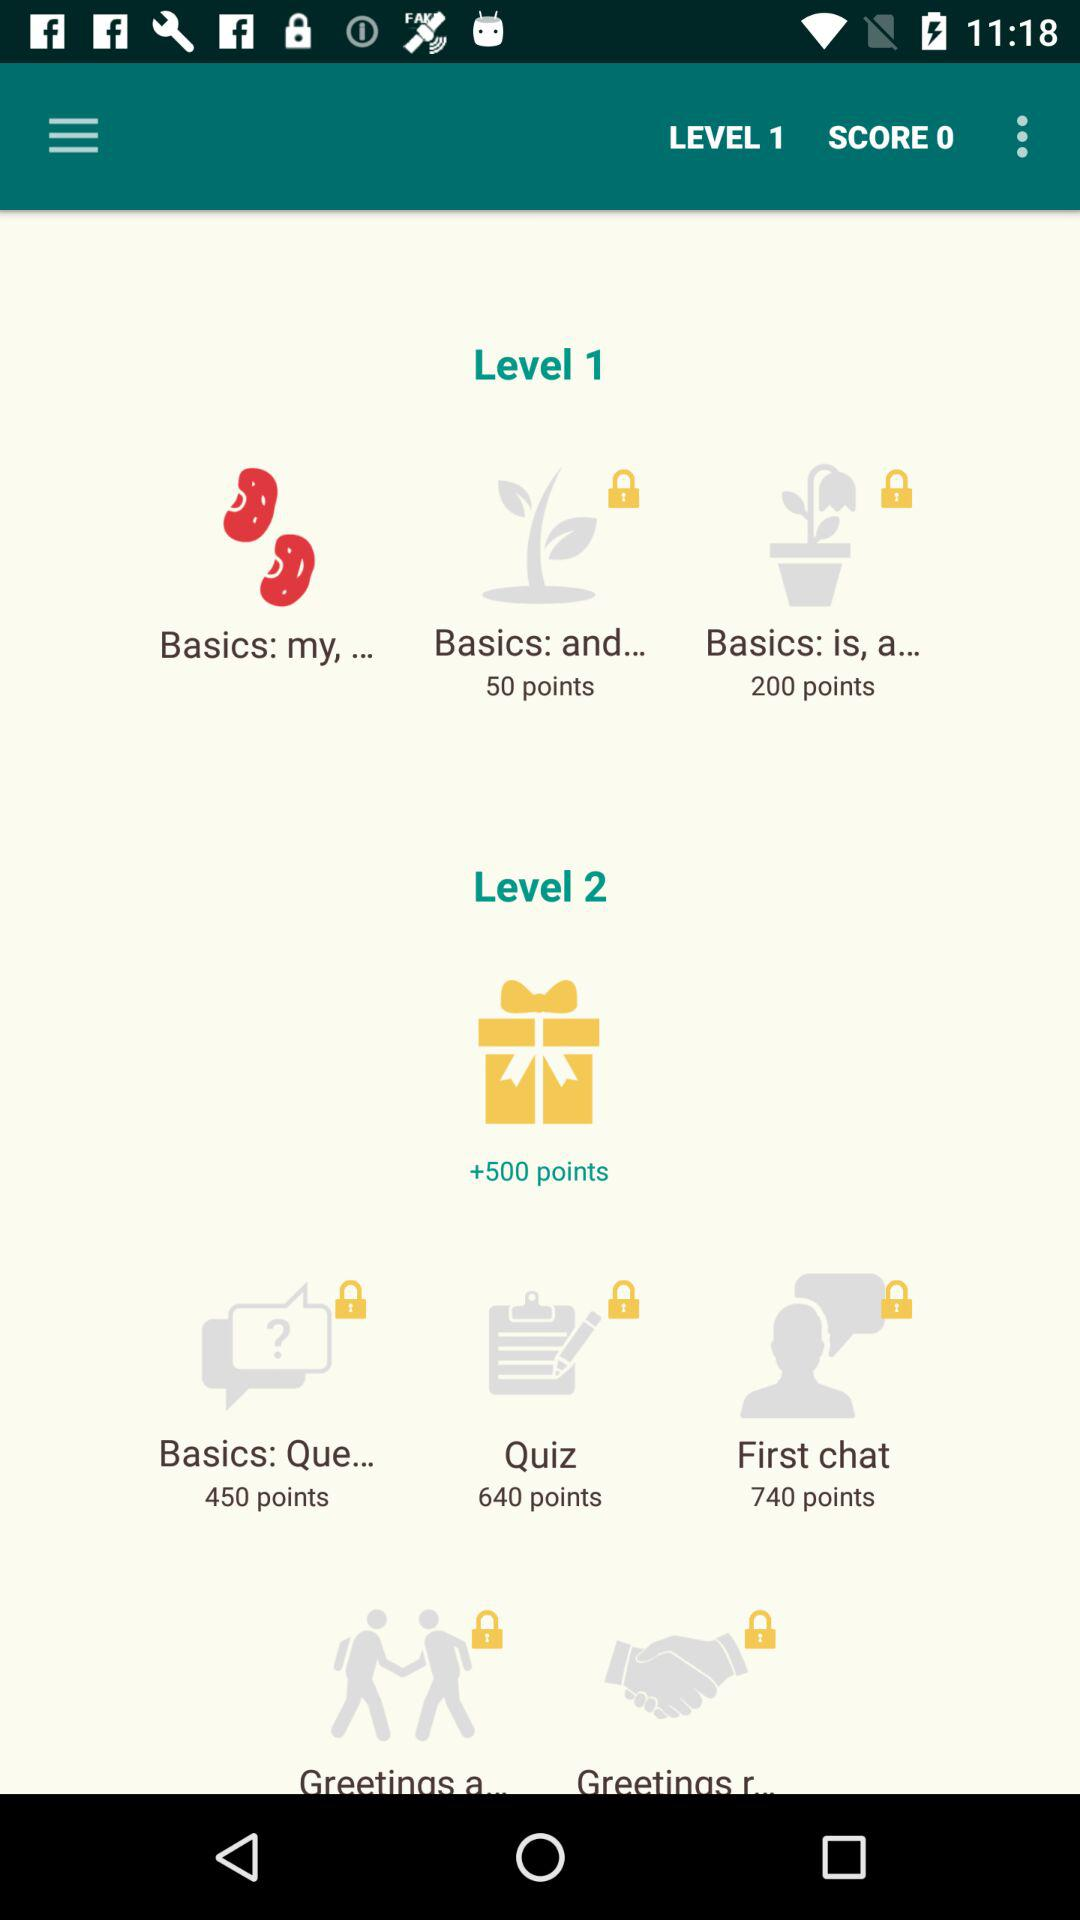How many quiz points are in level 2? There are 640 quiz points in level 2. 